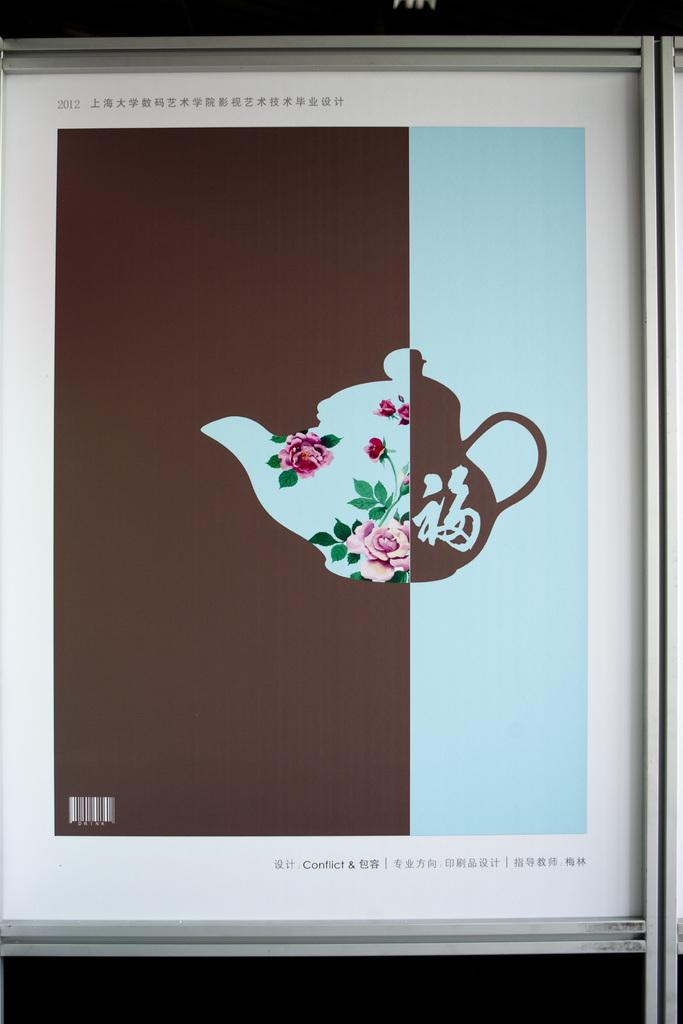<image>
Offer a succinct explanation of the picture presented. a tea pot on a screen with the word conflict on it 